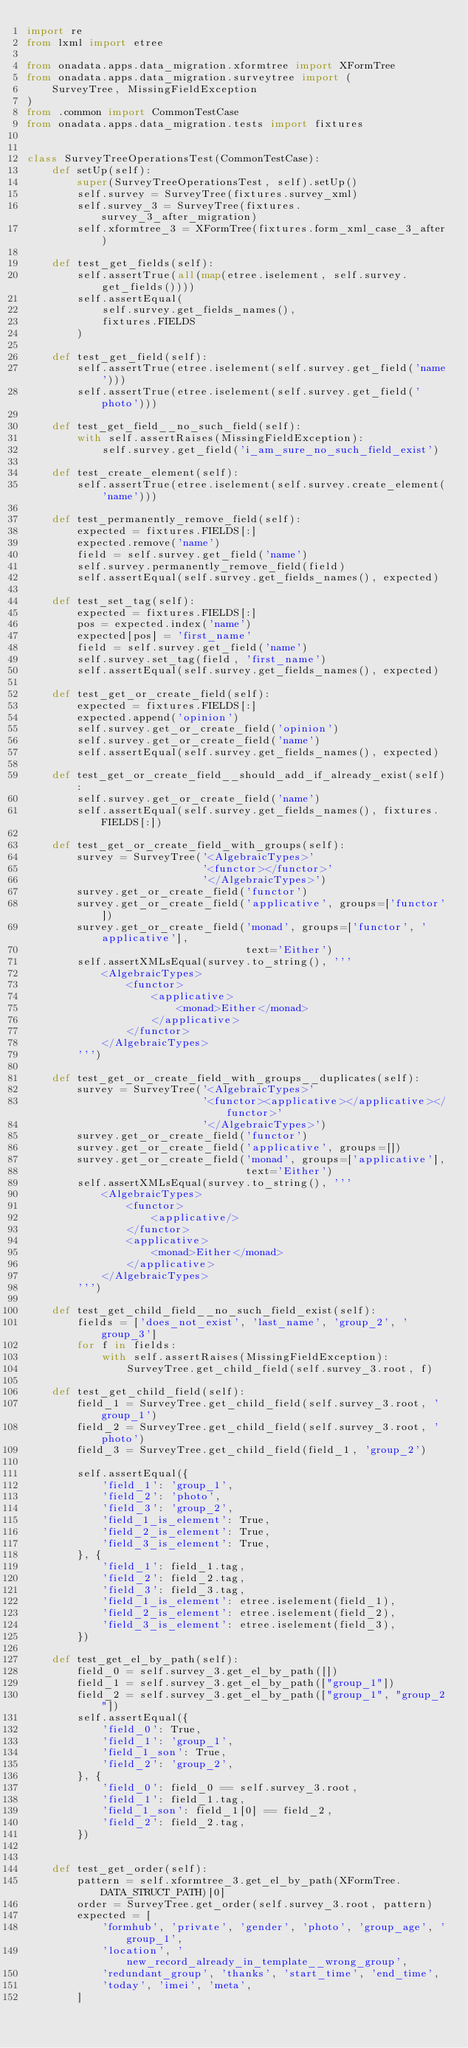Convert code to text. <code><loc_0><loc_0><loc_500><loc_500><_Python_>import re
from lxml import etree

from onadata.apps.data_migration.xformtree import XFormTree
from onadata.apps.data_migration.surveytree import (
    SurveyTree, MissingFieldException
)
from .common import CommonTestCase
from onadata.apps.data_migration.tests import fixtures


class SurveyTreeOperationsTest(CommonTestCase):
    def setUp(self):
        super(SurveyTreeOperationsTest, self).setUp()
        self.survey = SurveyTree(fixtures.survey_xml)
        self.survey_3 = SurveyTree(fixtures.survey_3_after_migration)
        self.xformtree_3 = XFormTree(fixtures.form_xml_case_3_after)

    def test_get_fields(self):
        self.assertTrue(all(map(etree.iselement, self.survey.get_fields())))
        self.assertEqual(
            self.survey.get_fields_names(),
            fixtures.FIELDS
        )

    def test_get_field(self):
        self.assertTrue(etree.iselement(self.survey.get_field('name')))
        self.assertTrue(etree.iselement(self.survey.get_field('photo')))

    def test_get_field__no_such_field(self):
        with self.assertRaises(MissingFieldException):
            self.survey.get_field('i_am_sure_no_such_field_exist')

    def test_create_element(self):
        self.assertTrue(etree.iselement(self.survey.create_element('name')))

    def test_permanently_remove_field(self):
        expected = fixtures.FIELDS[:]
        expected.remove('name')
        field = self.survey.get_field('name')
        self.survey.permanently_remove_field(field)
        self.assertEqual(self.survey.get_fields_names(), expected)

    def test_set_tag(self):
        expected = fixtures.FIELDS[:]
        pos = expected.index('name')
        expected[pos] = 'first_name'
        field = self.survey.get_field('name')
        self.survey.set_tag(field, 'first_name')
        self.assertEqual(self.survey.get_fields_names(), expected)

    def test_get_or_create_field(self):
        expected = fixtures.FIELDS[:]
        expected.append('opinion')
        self.survey.get_or_create_field('opinion')
        self.survey.get_or_create_field('name')
        self.assertEqual(self.survey.get_fields_names(), expected)

    def test_get_or_create_field__should_add_if_already_exist(self):
        self.survey.get_or_create_field('name')
        self.assertEqual(self.survey.get_fields_names(), fixtures.FIELDS[:])

    def test_get_or_create_field_with_groups(self):
        survey = SurveyTree('<AlgebraicTypes>'
                            '<functor></functor>'
                            '</AlgebraicTypes>')
        survey.get_or_create_field('functor')
        survey.get_or_create_field('applicative', groups=['functor'])
        survey.get_or_create_field('monad', groups=['functor', 'applicative'],
                                   text='Either')
        self.assertXMLsEqual(survey.to_string(), '''
            <AlgebraicTypes>
                <functor>
                    <applicative>
                        <monad>Either</monad>
                    </applicative>
                </functor>
            </AlgebraicTypes>
        ''')

    def test_get_or_create_field_with_groups__duplicates(self):
        survey = SurveyTree('<AlgebraicTypes>'
                            '<functor><applicative></applicative></functor>'
                            '</AlgebraicTypes>')
        survey.get_or_create_field('functor')
        survey.get_or_create_field('applicative', groups=[])
        survey.get_or_create_field('monad', groups=['applicative'],
                                   text='Either')
        self.assertXMLsEqual(survey.to_string(), '''
            <AlgebraicTypes>
                <functor>
                    <applicative/>
                </functor>
                <applicative>
                    <monad>Either</monad>
                </applicative>
            </AlgebraicTypes>
        ''')

    def test_get_child_field__no_such_field_exist(self):
        fields = ['does_not_exist', 'last_name', 'group_2', 'group_3']
        for f in fields:
            with self.assertRaises(MissingFieldException):
                SurveyTree.get_child_field(self.survey_3.root, f)

    def test_get_child_field(self):
        field_1 = SurveyTree.get_child_field(self.survey_3.root, 'group_1')
        field_2 = SurveyTree.get_child_field(self.survey_3.root, 'photo')
        field_3 = SurveyTree.get_child_field(field_1, 'group_2')

        self.assertEqual({
            'field_1': 'group_1',
            'field_2': 'photo',
            'field_3': 'group_2',
            'field_1_is_element': True,
            'field_2_is_element': True,
            'field_3_is_element': True,
        }, {
            'field_1': field_1.tag,
            'field_2': field_2.tag,
            'field_3': field_3.tag,
            'field_1_is_element': etree.iselement(field_1),
            'field_2_is_element': etree.iselement(field_2),
            'field_3_is_element': etree.iselement(field_3),
        })

    def test_get_el_by_path(self):
        field_0 = self.survey_3.get_el_by_path([])
        field_1 = self.survey_3.get_el_by_path(["group_1"])
        field_2 = self.survey_3.get_el_by_path(["group_1", "group_2"])
        self.assertEqual({
            'field_0': True,
            'field_1': 'group_1',
            'field_1_son': True,
            'field_2': 'group_2',
        }, {
            'field_0': field_0 == self.survey_3.root,
            'field_1': field_1.tag,
            'field_1_son': field_1[0] == field_2,
            'field_2': field_2.tag,
        })


    def test_get_order(self):
        pattern = self.xformtree_3.get_el_by_path(XFormTree.DATA_STRUCT_PATH)[0]
        order = SurveyTree.get_order(self.survey_3.root, pattern)
        expected = [
            'formhub', 'private', 'gender', 'photo', 'group_age', 'group_1',
            'location', 'new_record_already_in_template__wrong_group',
            'redundant_group', 'thanks', 'start_time', 'end_time',
            'today', 'imei', 'meta',
        ]</code> 